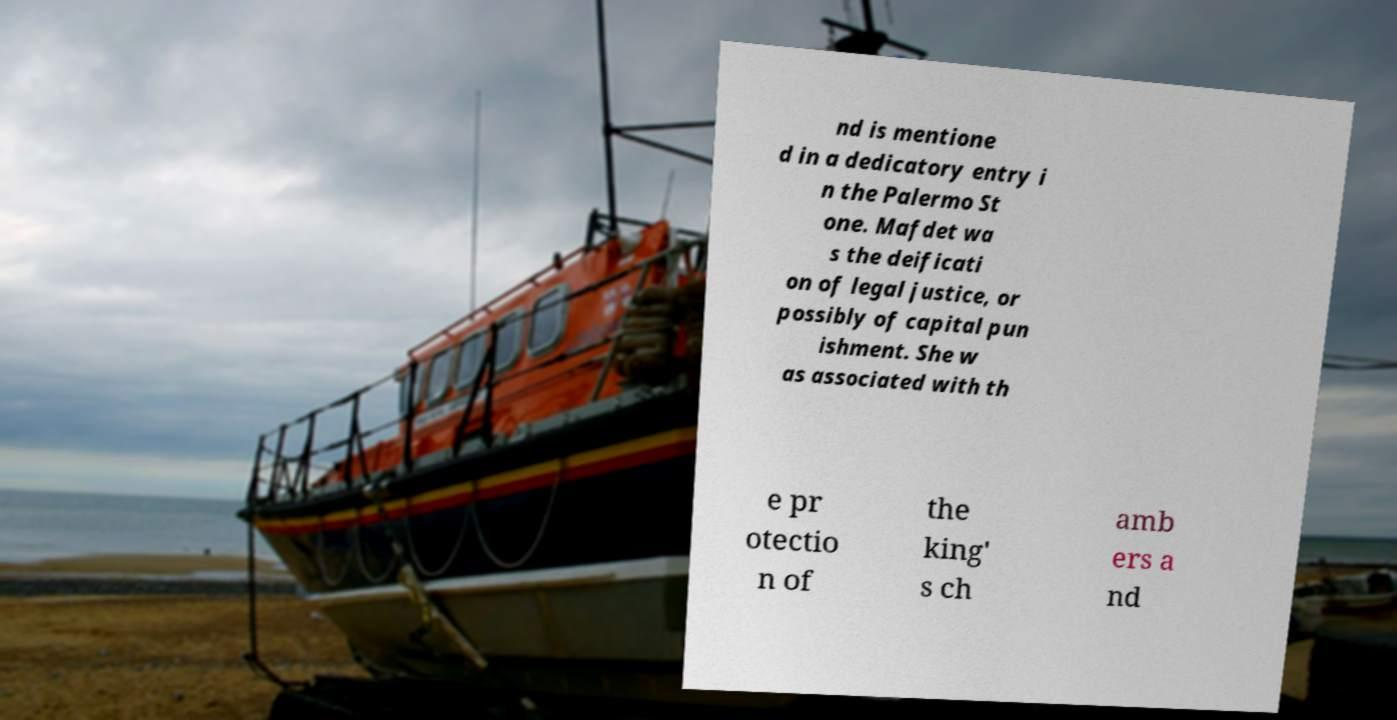For documentation purposes, I need the text within this image transcribed. Could you provide that? nd is mentione d in a dedicatory entry i n the Palermo St one. Mafdet wa s the deificati on of legal justice, or possibly of capital pun ishment. She w as associated with th e pr otectio n of the king' s ch amb ers a nd 